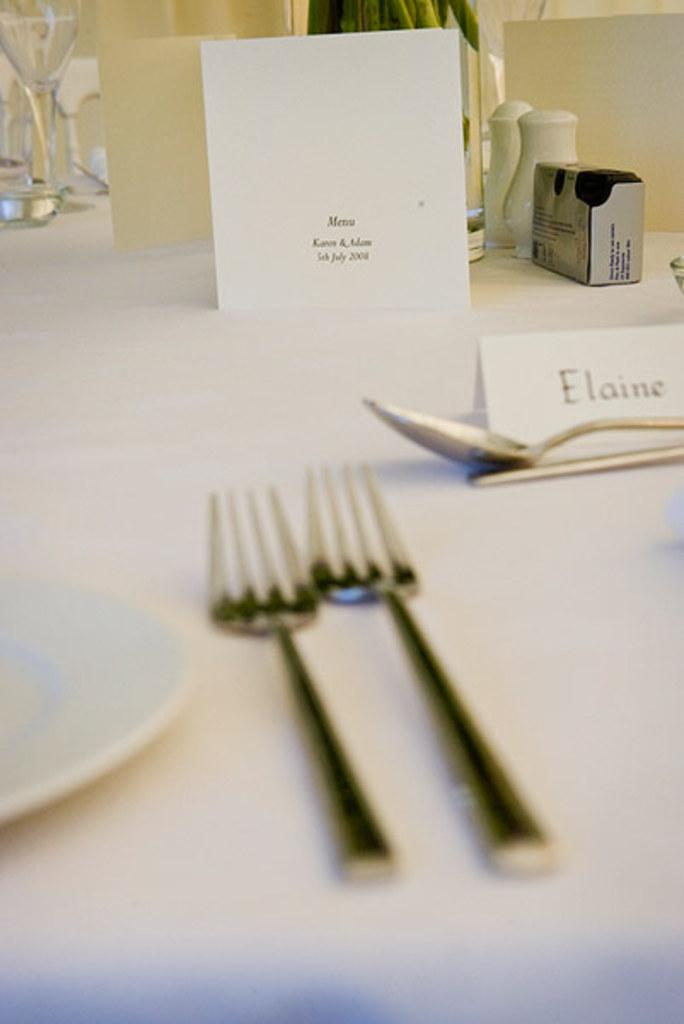How many forks are on the table in the image? There are two forks on the table in the image. What other utensils are on the table? The table includes spoons. What types of items are on the table besides utensils? The table includes platters, card boards, papers, boxes, containers, and glasses. Is there any greenery on the table? Yes, there is a plant on the table in the image. What type of behavior does the donkey exhibit in the image? There is no donkey present in the image, so it is not possible to determine its behavior. 